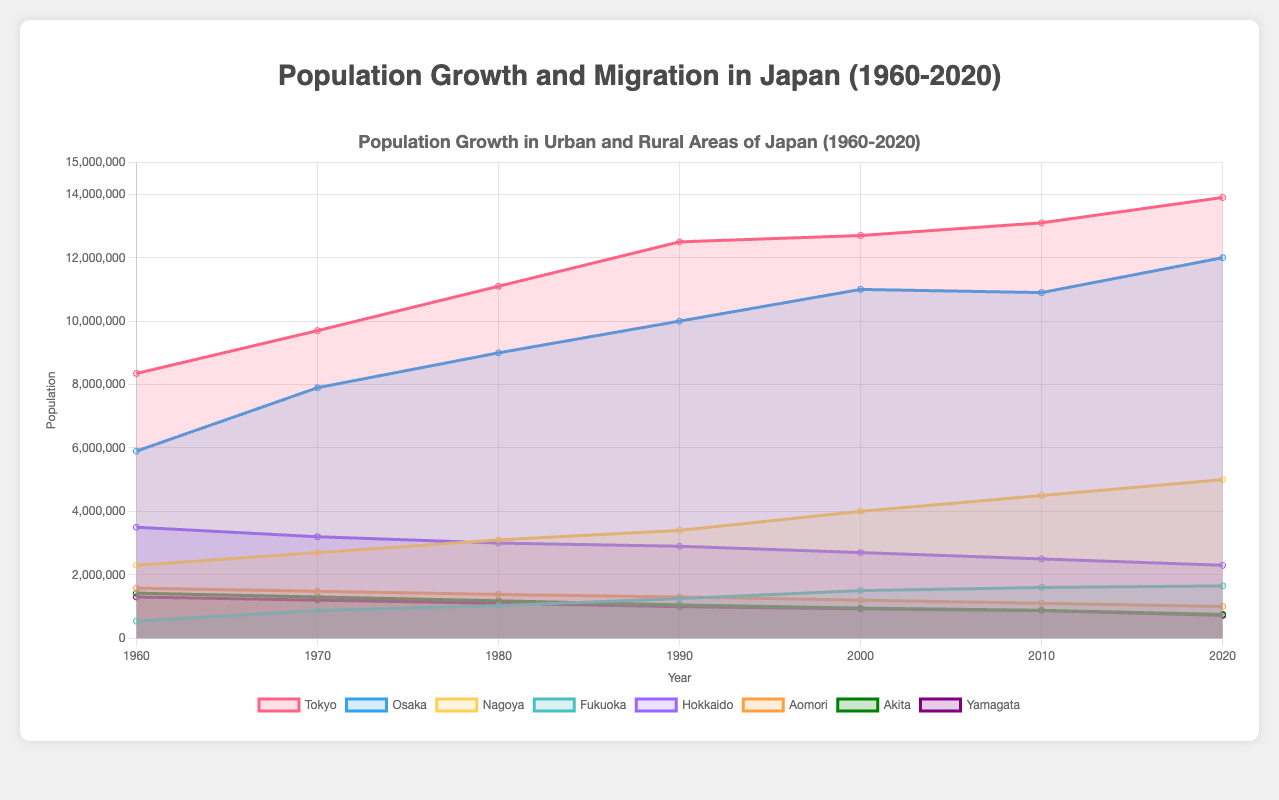What's the title of the chart? The title is placed at the top of the chart and it reads "Population Growth in Urban and Rural Areas of Japan (1960-2020)".
Answer: Population Growth in Urban and Rural Areas of Japan (1960-2020) Which city had the highest urban population in 2020? By observing the colored regions representing different cities, Tokyo has the tallest filled area in 2020, indicating the highest urban population.
Answer: Tokyo How many urban and rural areas are represented in the chart? The chart has labeled datasets for Tokyo, Osaka, Nagoya, and Fukuoka (urban areas), and for Hokkaido, Aomori, Akita, and Yamagata (rural areas).
Answer: 8 Calculate the increase in urban population in Tokyo from 1960 to 2020. Urban population in Tokyo in 1960 was 8,350,000 and in 2020 it was 13,900,000. The increase is calculated as 13,900,000 - 8,350,000 = 5,550,000.
Answer: 5,550,000 Which rural area showed the most significant decline in population from 1960 to 2020? By comparing the heights of the filled regions for rural populations, Akita shows the most significant decline, decreasing from 1,420,000 in 1960 to 750,000 in 2020.
Answer: Akita Compare the migration patterns for Tokyo and Osaka in the year 2000. According to the migration dataset, Tokyo had 650,000 people migrating in 2000, while Osaka had 480,000. So, Tokyo had more migration.
Answer: Tokyo What is the average population of Fukuoka from 1960 to 2020? Add the population values of Fukuoka for the years (540,000 + 870,000 + 1,030,000 + 1,250,000 + 1,500,000 + 1,600,000 + 1,650,000) and divide by the number of data points, which is 7. Average is (540,000 + 870,000 + 1,030,000 + 1,250,000 + 1,500,000 + 1,600,000 + 1,650,000) / 7 = 6,440,000 / 7 = 920,000.
Answer: 920,000 Between Hokkaido and Aomori, which rural area had the highest population in 1980? By examining the chart, in 1980, Hokkaido had a population of 3,000,000, while Aomori had 1,380,000. Thus, Hokkaido had the highest population.
Answer: Hokkaido How did the population trend for Nagoya change from 1990 to 2020? From 1990 (3,400,000) to 2020 (5,000,000), Nagoya's population showed a continuous upward trend, indicating growth throughout these years.
Answer: Upward trend What was the migration pattern for Yamagata in 1980? According to the migration pattern dataset, Yamagata had a migration number of 30,000 in 1980.
Answer: 30,000 